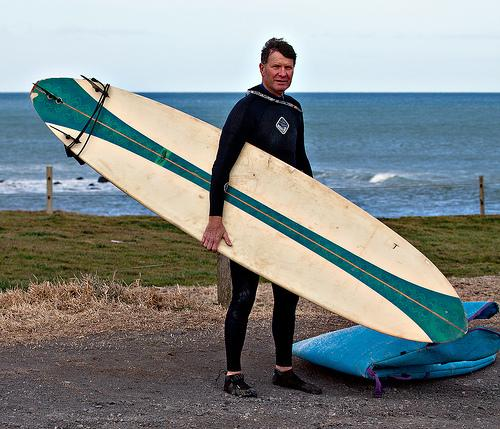Identify the primary subject in the image and describe their physical appearance. The primary subject is a man with brown short hair, wearing a black wetsuit with a white and blue logo, and black shoes. Discuss the sentiment or mood conveyed by the image through its elements and subject matter. The image conveys a sense of adventure and leisure as the man is about to surf in the blue ocean amid beautiful surroundings. Analyze the interaction between the man and the surfboard in the image. The man is holding the surfboard with his right arm, showcasing an intention to go surfing and a sense of connection with the sport. Identify the primary person in the image and describe the activity they are engaged in. The primary person is a man wearing a black wetsuit, holding a white and blue surfboard while standing on a road. In one sentence, provide an overall description of the image's setting and environment. The image shows a man with a surfboard standing near the ocean, with grass, sky, and waves in the background. Assess the overall quality of the image based on its components, such as objects and background elements. The image is of good quality with clear objects and background elements like the man, surfboard, waves, grass, and sky. Describe the surfboard's design and color, as well as any visible attachments or features. The surfboard is white and blue with a rope on it and a purple handle, and it also has a folded blue surfboard cover. Describe the various background elements of the image, and how they contribute to the overall scene. The background includes waves, sky, grass, and posts, which provide context for the man's surroundings and create a picturesque setting for his surfing adventure. Count the number of wooden posts found in the grass in the background of the image. There are 2 wooden posts found in the grass. Can you see the orange traffic cone near the wooden post? No, it's not mentioned in the image. Does the man have long blonde hair? The man in the image is described as having brown short hair, not long blonde hair. This instruction is misleading because it contradicts the given information about the man's hair. Is the man in the black wetsuit holding a pink surfboard? There is no mention of a pink surfboard in the image; therefore, this instruction refers to a non-existent object within the given data. Can you find the red flowers in the grass? There are no red flowers mentioned in the image at all; the image only includes dried brown grass in the background. Is the man wearing a white wet suit? The man in the image is wearing a black wet suit, not a white one. The instruction is misleading because it is providing incorrect information about the man's wet suit color. 